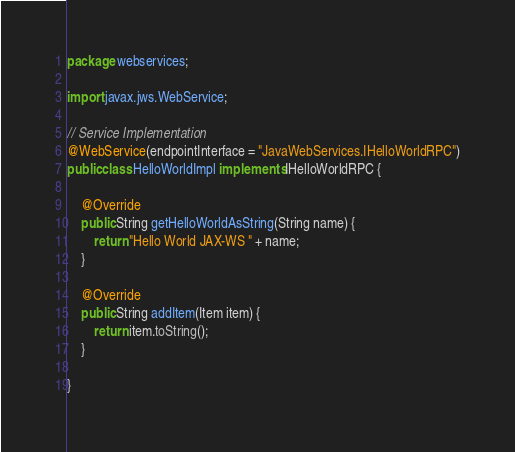Convert code to text. <code><loc_0><loc_0><loc_500><loc_500><_Java_>package webservices;

import javax.jws.WebService;

// Service Implementation
@WebService(endpointInterface = "JavaWebServices.IHelloWorldRPC")
public class HelloWorldImpl implements IHelloWorldRPC {

	@Override
	public String getHelloWorldAsString(String name) {
		return "Hello World JAX-WS " + name;
	}

	@Override
	public String addItem(Item item) {
		return item.toString();
	}

}
</code> 